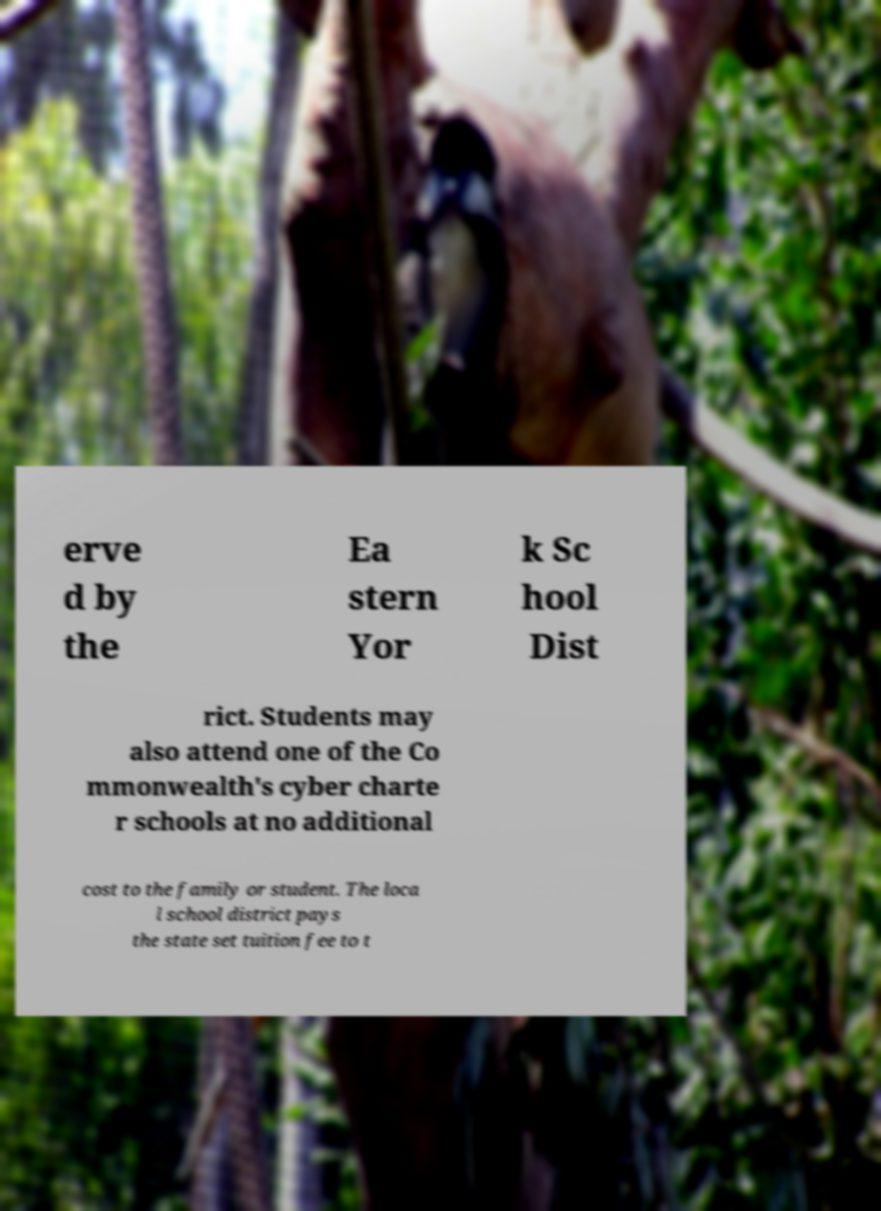For documentation purposes, I need the text within this image transcribed. Could you provide that? erve d by the Ea stern Yor k Sc hool Dist rict. Students may also attend one of the Co mmonwealth's cyber charte r schools at no additional cost to the family or student. The loca l school district pays the state set tuition fee to t 